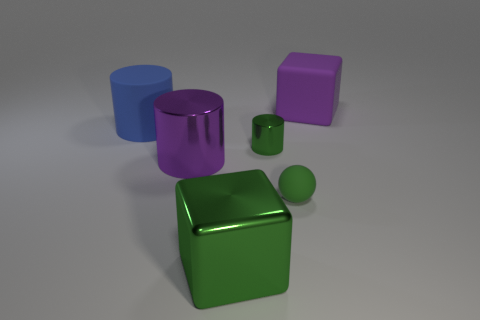Could you guess the material these objects are made of based on their appearance? Based on their appearance, all the objects exhibit shiny surfaces that suggest they might be made of a metallic material. This is evident due to the light reflecting off their surfaces, giving them a lustrous look. 